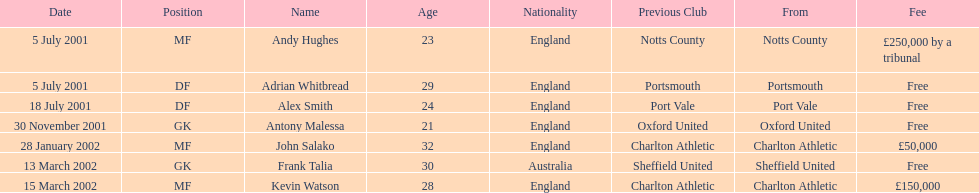What is the total number of free fees? 4. Would you be able to parse every entry in this table? {'header': ['Date', 'Position', 'Name', 'Age', 'Nationality', 'Previous Club', 'From', 'Fee'], 'rows': [['5 July 2001', 'MF', 'Andy Hughes', '23', 'England', 'Notts County', 'Notts County', '£250,000 by a tribunal'], ['5 July 2001', 'DF', 'Adrian Whitbread', '29', 'England', 'Portsmouth', 'Portsmouth', 'Free'], ['18 July 2001', 'DF', 'Alex Smith', '24', 'England', 'Port Vale', 'Port Vale', 'Free'], ['30 November 2001', 'GK', 'Antony Malessa', '21', 'England', 'Oxford United', 'Oxford United', 'Free'], ['28 January 2002', 'MF', 'John Salako', '32', 'England', 'Charlton Athletic', 'Charlton Athletic', '£50,000'], ['13 March 2002', 'GK', 'Frank Talia', '30', 'Australia', 'Sheffield United', 'Sheffield United', 'Free'], ['15 March 2002', 'MF', 'Kevin Watson', '28', 'England', 'Charlton Athletic', 'Charlton Athletic', '£150,000']]} 